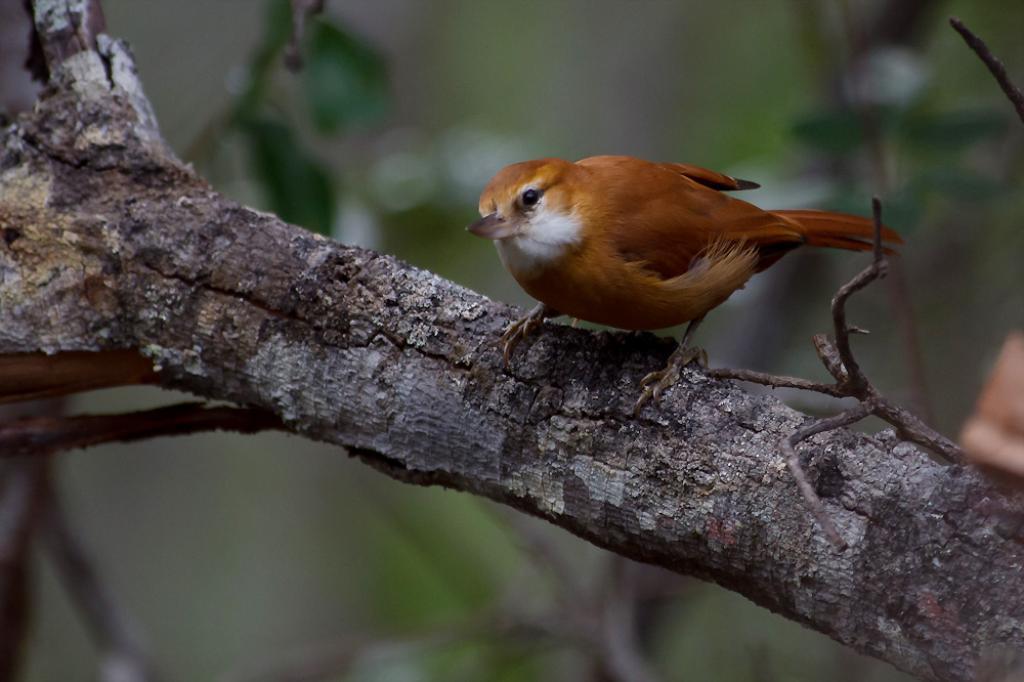Can you describe this image briefly? In this picture we can see a brown bird on a wooden branch. 